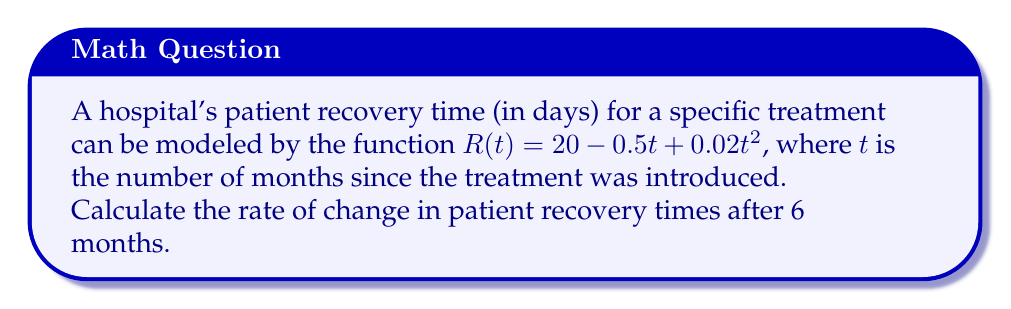Could you help me with this problem? To find the rate of change in patient recovery times, we need to calculate the derivative of the given function and evaluate it at $t = 6$.

Step 1: Find the derivative of $R(t)$.
$$\frac{d}{dt}R(t) = \frac{d}{dt}(20 - 0.5t + 0.02t^2)$$
$$R'(t) = 0 - 0.5 + 0.04t$$

Step 2: Simplify the derivative.
$$R'(t) = -0.5 + 0.04t$$

Step 3: Evaluate the derivative at $t = 6$.
$$R'(6) = -0.5 + 0.04(6)$$
$$R'(6) = -0.5 + 0.24$$
$$R'(6) = -0.26$$

The negative value indicates that the recovery time is decreasing at this point.
Answer: $-0.26$ days/month 